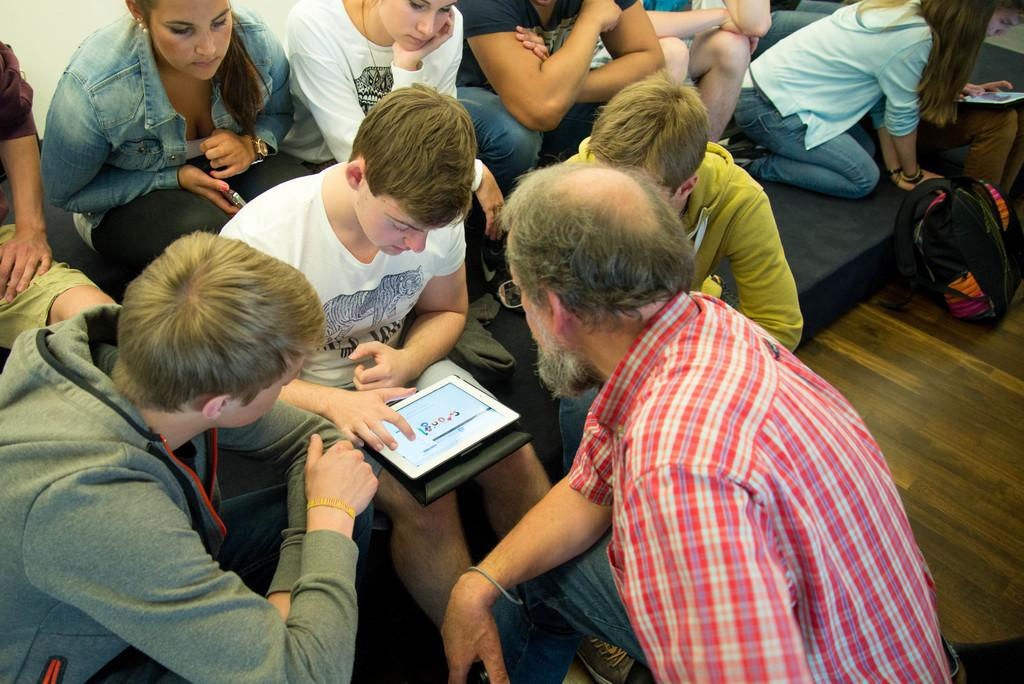What is the main activity of the people in the image? There is a group of people sitting in the image. What are two of the people holding? Two persons are holding tabs. Where is the bag located in the image? There is a bag on the floor on the right side of the image. What type of star can be seen in the image? There is no star present in the image. What subject are the people teaching in the image? There is no indication of teaching or a specific subject in the image. 